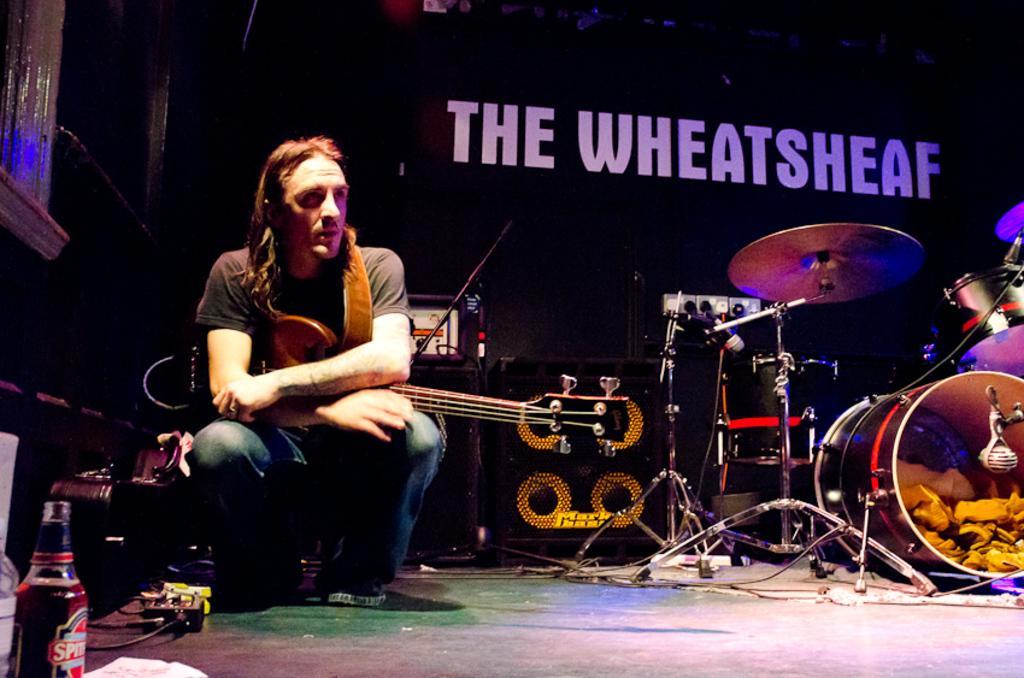Could you give a brief overview of what you see in this image? In this picture there is a man sitting like squat position and holding a guitar. We can see musical instruments, devices, cables, bottle and objects. In the background of the image it is dark and we can see text. 